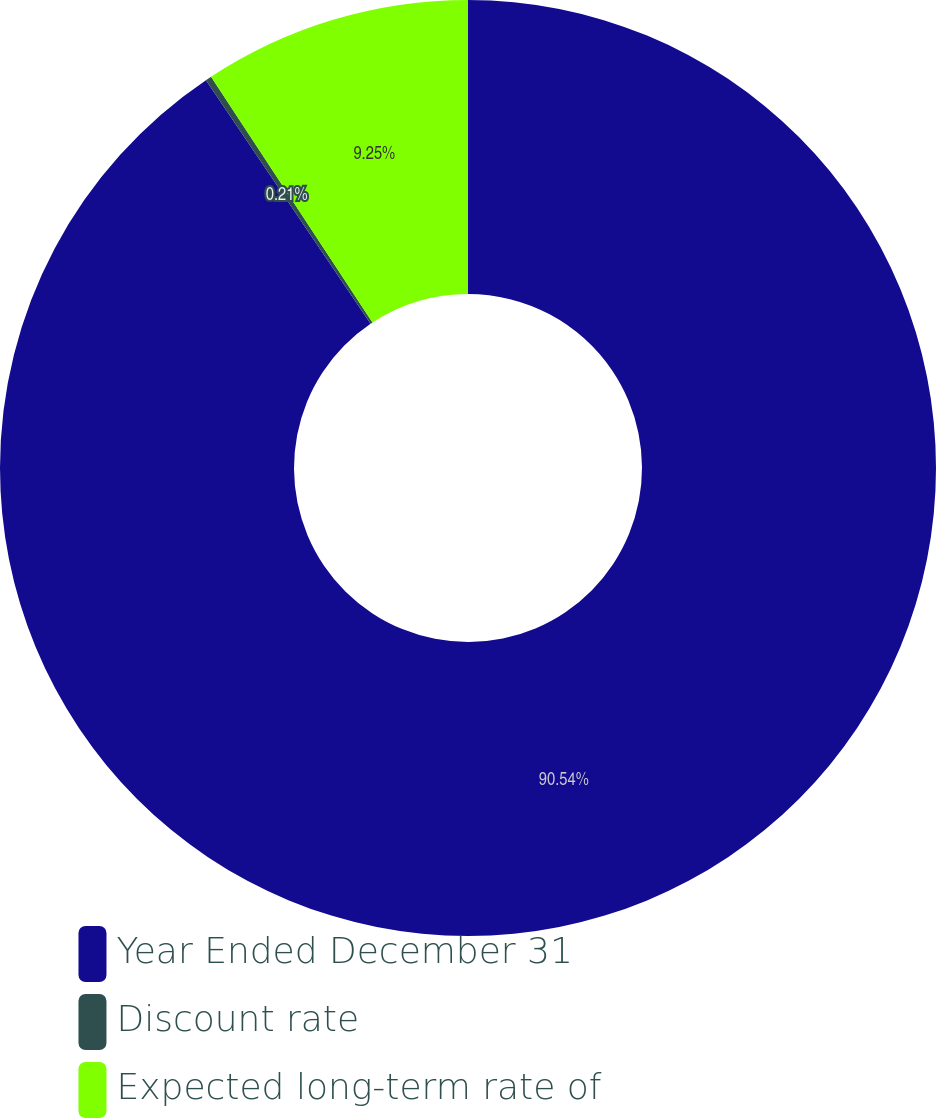<chart> <loc_0><loc_0><loc_500><loc_500><pie_chart><fcel>Year Ended December 31<fcel>Discount rate<fcel>Expected long-term rate of<nl><fcel>90.54%<fcel>0.21%<fcel>9.25%<nl></chart> 